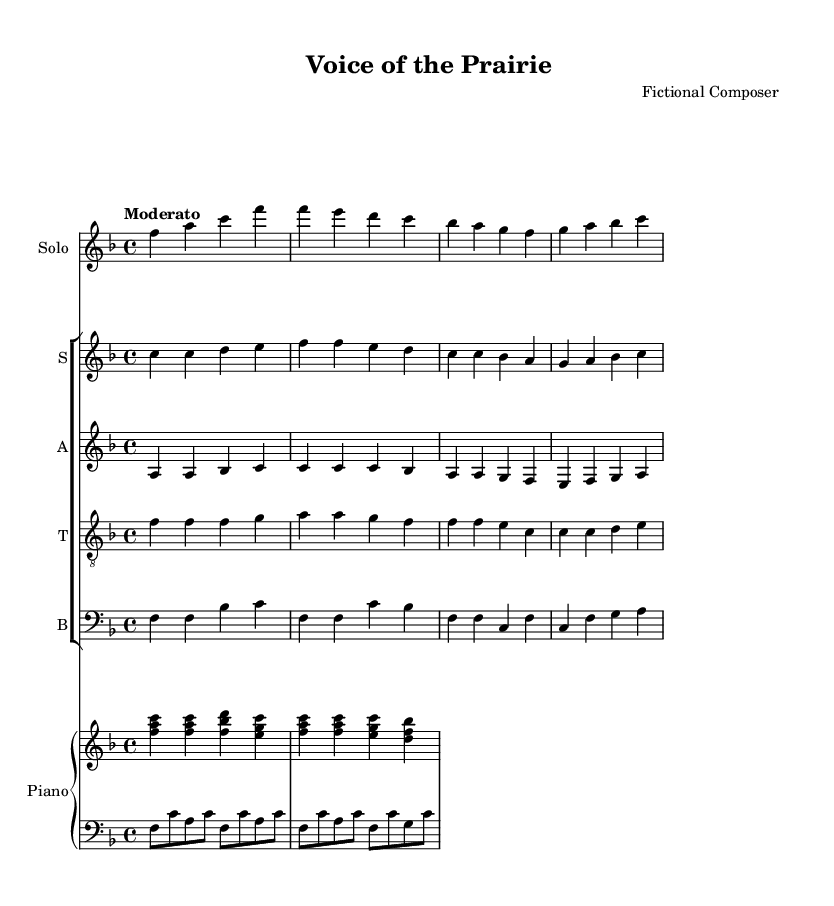What is the key signature of this music? The key signature is F major, which has one flat (B flat). This can be observed in the key signature section at the beginning of the sheet music.
Answer: F major What is the time signature of the piece? The time signature is 4/4, indicated at the beginning of the sheet music. This means there are four beats in each measure and a quarter note receives one beat.
Answer: 4/4 What is the tempo marking for this piece? The tempo marking is "Moderato," which suggests a moderate pace for performance. It is stated at the beginning of the score above the staff.
Answer: Moderato How many verses are present in the vocal part? There is one verse provided in the lyrics for the soprano choir, which can be identified by counting the lyric sections indicated in the melody line.
Answer: One In what location is civic engagement emphasized in the lyrics? Civic engagement is emphasized in the lyrics with the lines "Let freedom ring across the land," which suggest the idea of active participation in democracy, showing a connection to civic duties.
Answer: Freedom ring across the land What type of ensemble is indicated in the score? The score indicates a mixed choir, as it contains separate parts for soprano, alto, tenor, and bass voices, implying a variety of vocal ranges typical of choir music.
Answer: Mixed choir What is the main thematic focus of this opera? The main thematic focus is on American democracy and civic engagement, as seen in the lyrics that reference unity, freedom, and the sacred nature of the right to vote.
Answer: American democracy 